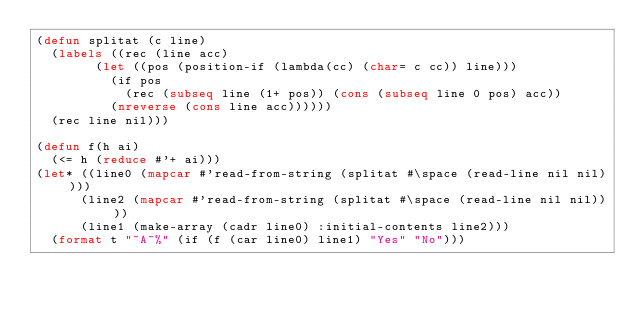<code> <loc_0><loc_0><loc_500><loc_500><_Lisp_>(defun splitat (c line)
  (labels ((rec (line acc)
				(let ((pos (position-if (lambda(cc) (char= c cc)) line)))
				  (if pos
					  (rec (subseq line (1+ pos)) (cons (subseq line 0 pos) acc))
					(nreverse (cons line acc))))))
	(rec line nil)))

(defun f(h ai)
  (<= h (reduce #'+ ai)))
(let* ((line0 (mapcar #'read-from-string (splitat #\space (read-line nil nil))))
      (line2 (mapcar #'read-from-string (splitat #\space (read-line nil nil))))
      (line1 (make-array (cadr line0) :initial-contents line2)))
  (format t "~A~%" (if (f (car line0) line1) "Yes" "No")))
</code> 